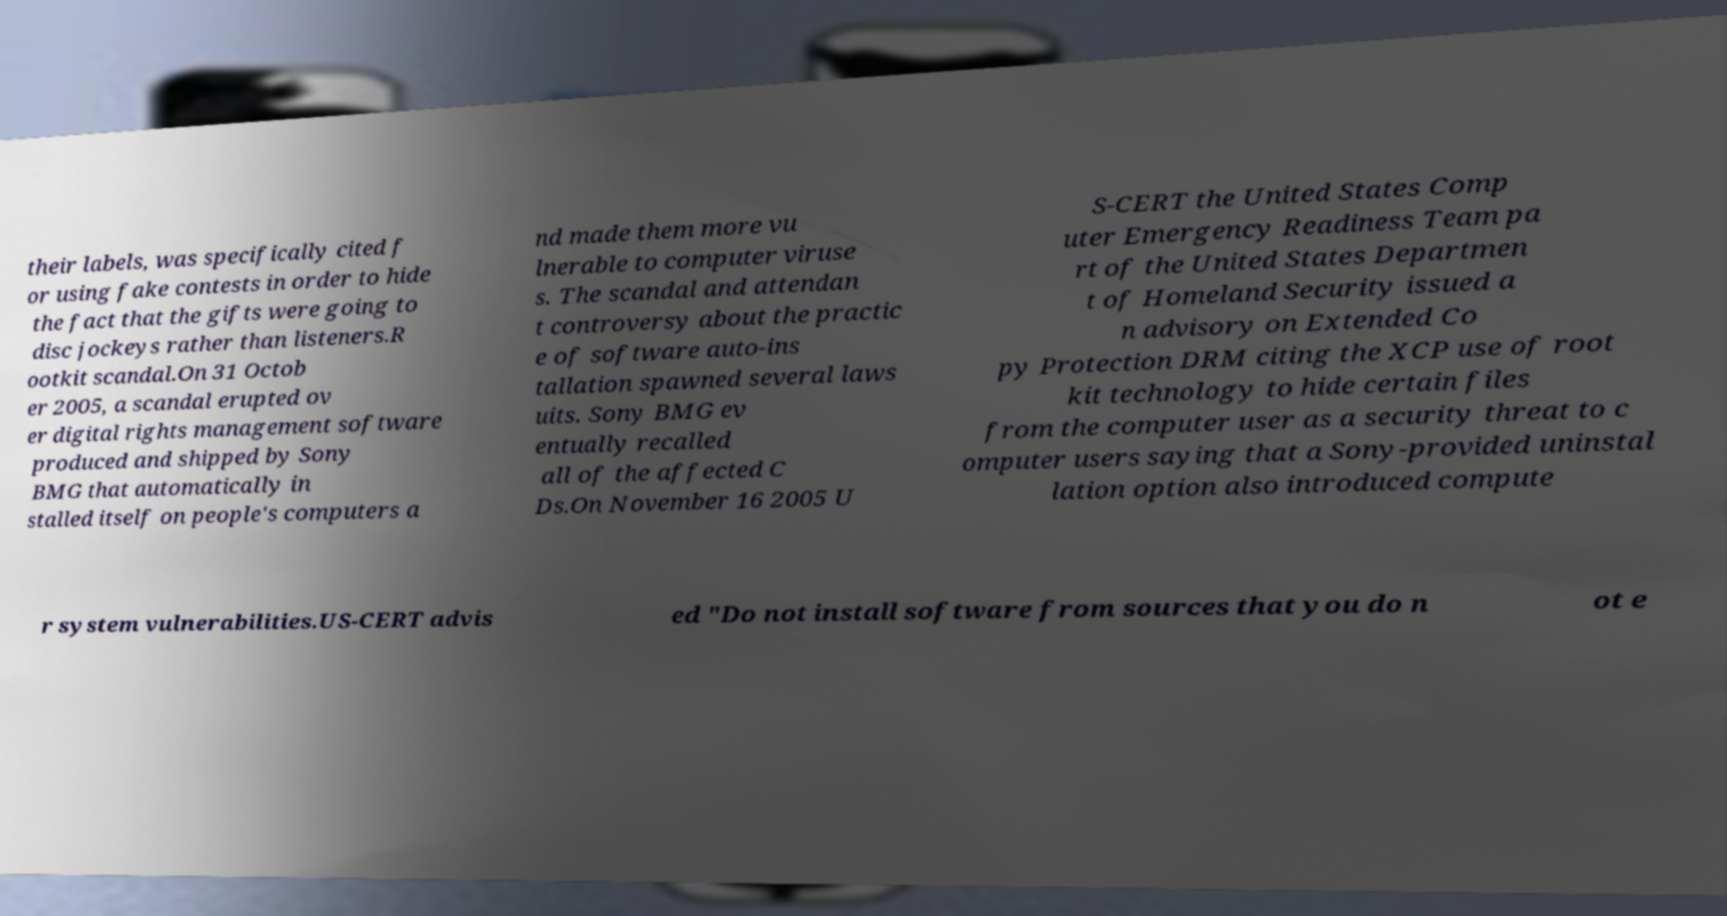Please read and relay the text visible in this image. What does it say? their labels, was specifically cited f or using fake contests in order to hide the fact that the gifts were going to disc jockeys rather than listeners.R ootkit scandal.On 31 Octob er 2005, a scandal erupted ov er digital rights management software produced and shipped by Sony BMG that automatically in stalled itself on people's computers a nd made them more vu lnerable to computer viruse s. The scandal and attendan t controversy about the practic e of software auto-ins tallation spawned several laws uits. Sony BMG ev entually recalled all of the affected C Ds.On November 16 2005 U S-CERT the United States Comp uter Emergency Readiness Team pa rt of the United States Departmen t of Homeland Security issued a n advisory on Extended Co py Protection DRM citing the XCP use of root kit technology to hide certain files from the computer user as a security threat to c omputer users saying that a Sony-provided uninstal lation option also introduced compute r system vulnerabilities.US-CERT advis ed "Do not install software from sources that you do n ot e 